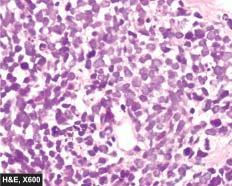re scanty cytoplasm and markedly hyperchromatic nuclei arranged in sheets, cords or aggregates and at places form pseudorosettes?
Answer the question using a single word or phrase. No 